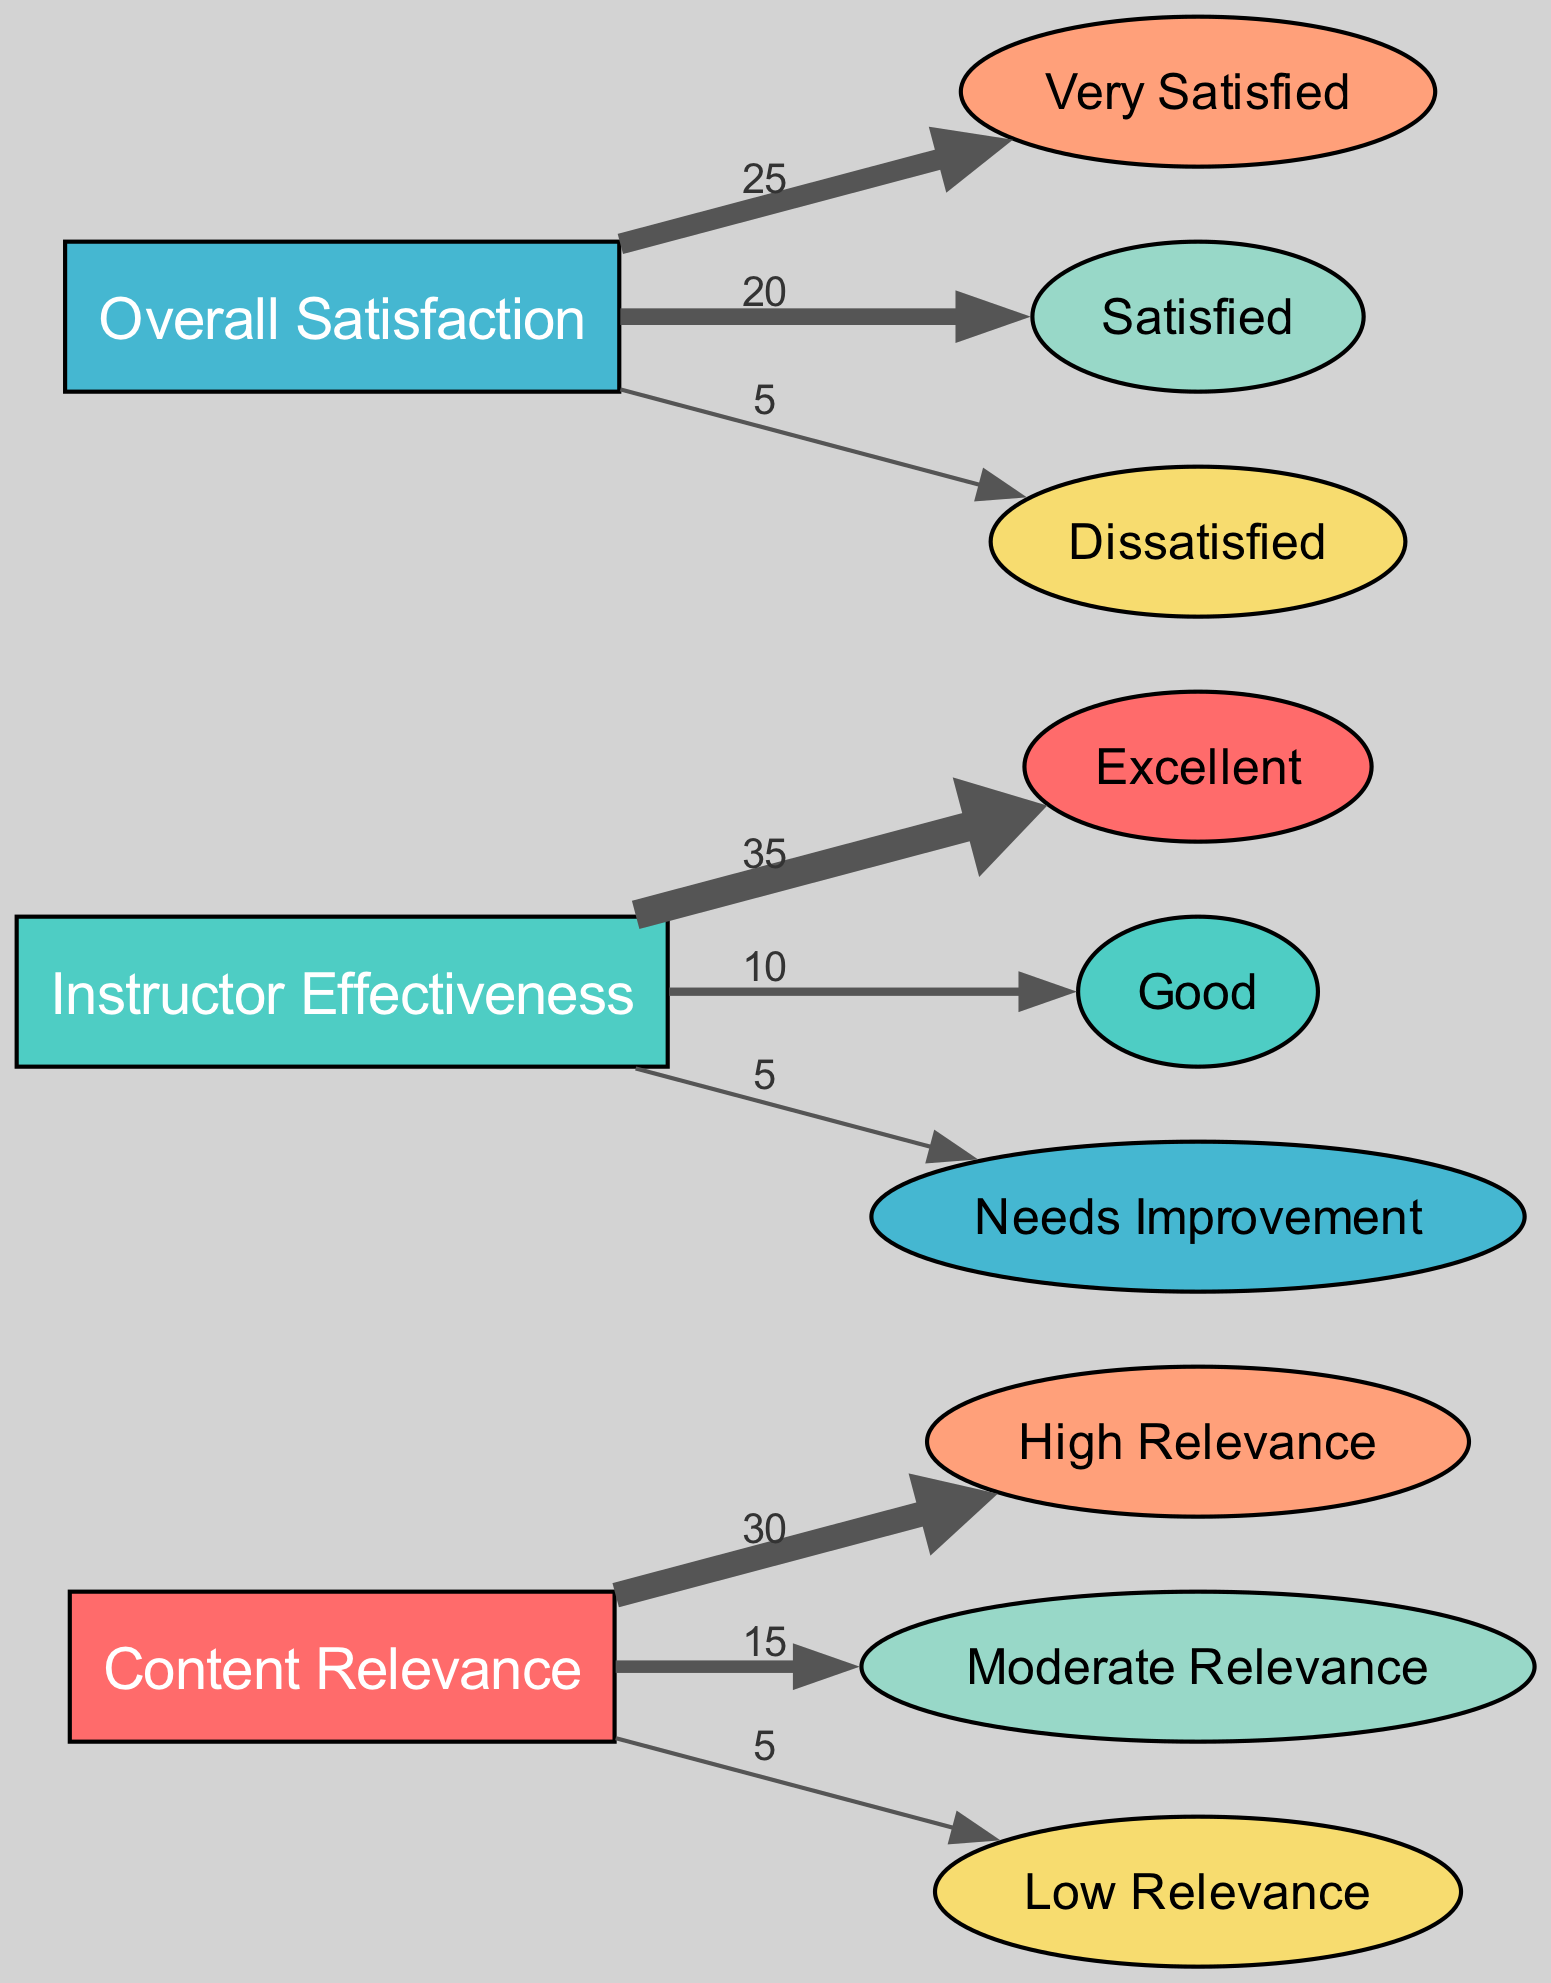What is the total number of nodes in the diagram? The diagram has a total of 12 nodes listed under the "nodes" section of the data provided. This includes the themes as well as the feedback ratings for each theme.
Answer: 12 What is the value of links from "content_relevance" to "high_relevance"? The value for the link between "content_relevance" and "high_relevance" is 30, as stated in the dataset under the links section.
Answer: 30 How many feedback comments fall under "needs_improvement" for "instructor_effectiveness"? The value for the link from "instructor_effectiveness" to "needs_improvement" is 5, indicating 5 feedback responses categorized under that label.
Answer: 5 What percentage of participants rated "overall_satisfaction" as "very_satisfied"? "Very satisfied" has a value of 25 out of 50 total satisfaction responses (25+20+5), which gives a percentage of 50%.
Answer: 50% Which feedback theme received the highest number of positive responses, as indicated by the links? The "instructor_effectiveness" theme received the highest positive response with 35 links leading to "excellent", which is the highest single value in the diagram.
Answer: 35 If someone rated their "content_relevance" as "low_relevance", how many participants is that? The value for "low_relevance" linked to "content_relevance" is 5, meaning 5 participants rated it as such.
Answer: 5 What is the relationship between "instructor_effectiveness" and "overall_satisfaction"? The diagram indicates that while both are themes for collecting feedback, they are visually separate with links connecting to rating outcomes, showing that each theme has independent sets of feedback values.
Answer: Independent Which feedback category has the least amount of comments? The category with the least amount of comments is "low_relevance", with a total of 5 responses linked to "content_relevance".
Answer: Low Relevance What is the combined value of satisfied and very satisfied ratings in overall satisfaction? The combined value is 45, made up of 25 from "very_satisfied" and 20 from "satisfied".
Answer: 45 